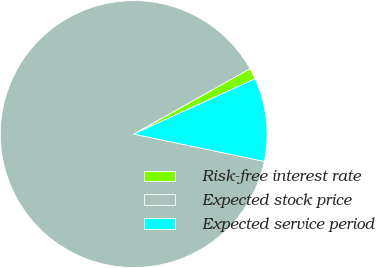<chart> <loc_0><loc_0><loc_500><loc_500><pie_chart><fcel>Risk-free interest rate<fcel>Expected stock price<fcel>Expected service period<nl><fcel>1.36%<fcel>88.56%<fcel>10.08%<nl></chart> 